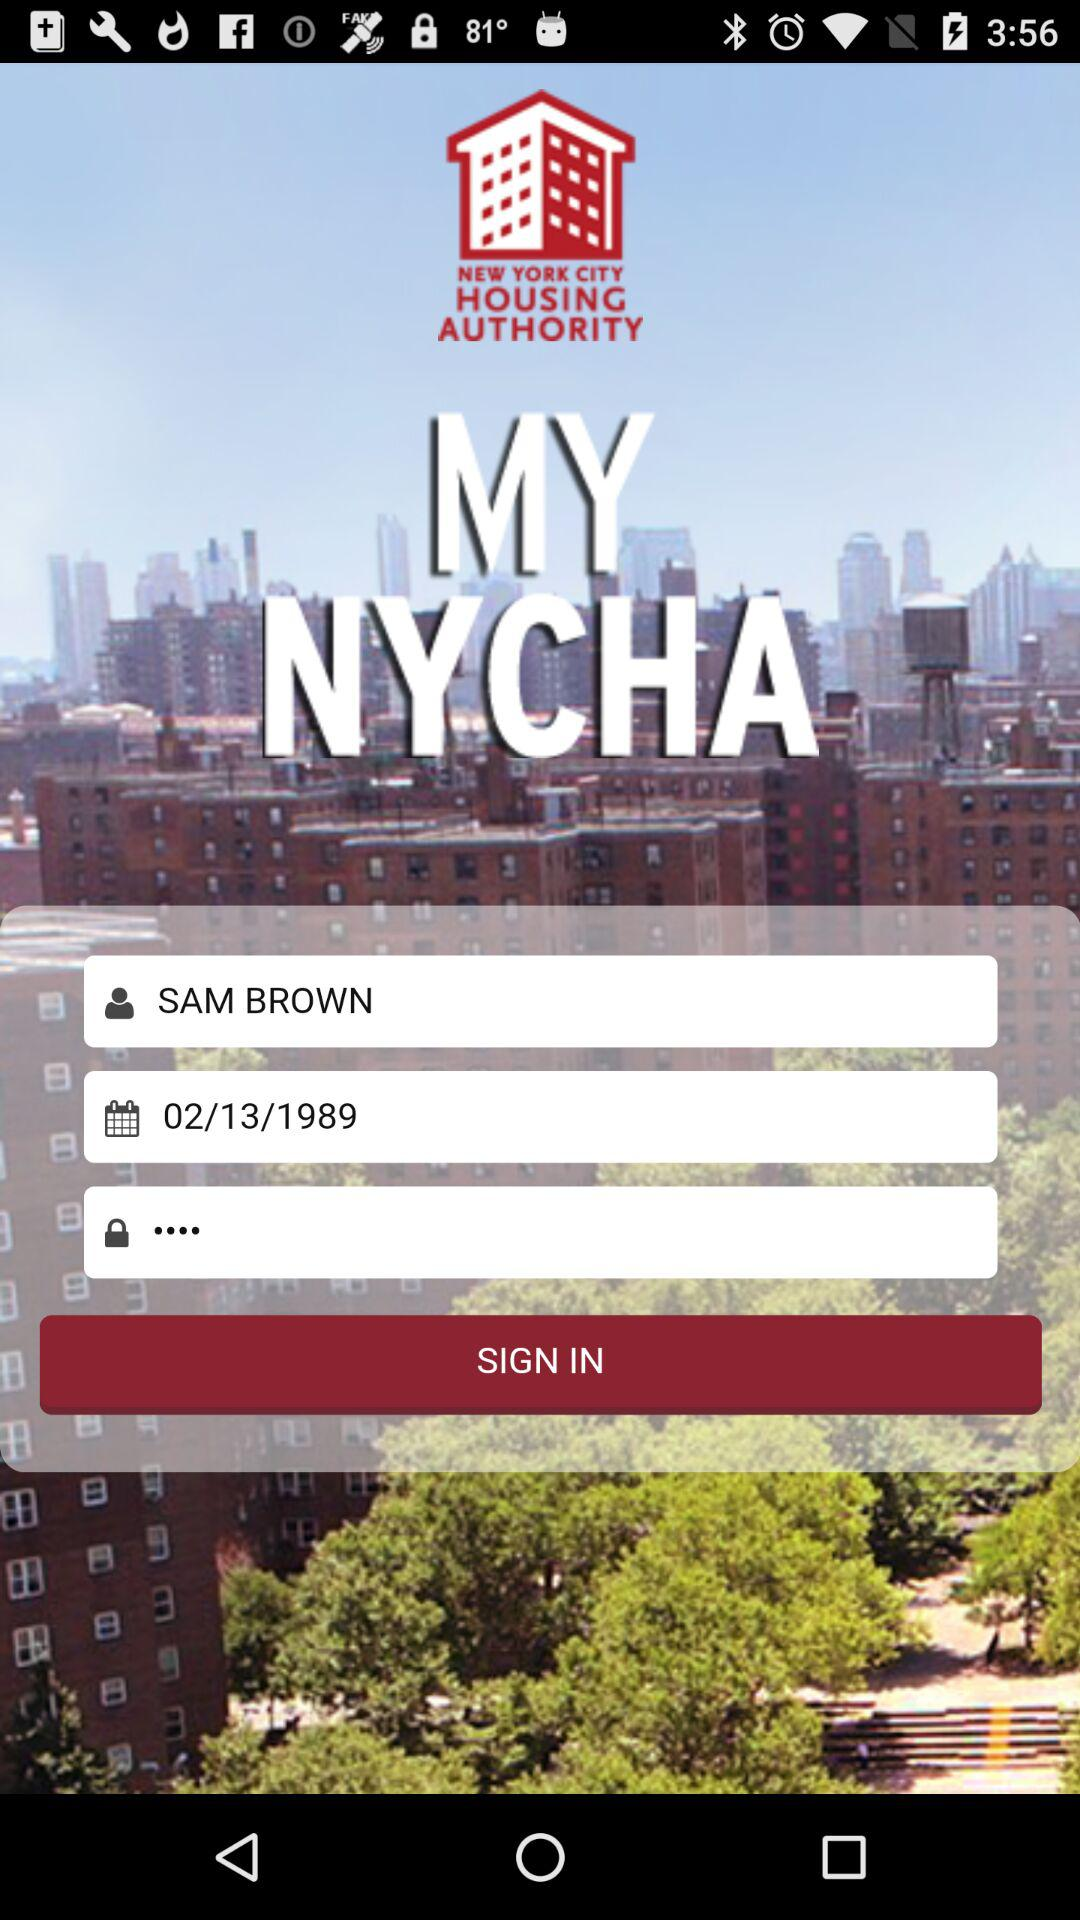What is the login name? The login name is Sam Brown. 